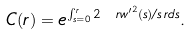<formula> <loc_0><loc_0><loc_500><loc_500>C ( r ) = e ^ { \int _ { s = 0 } ^ { r } 2 { \ r w ^ { \prime } } ^ { 2 } ( s ) / s \, r d s } .</formula> 